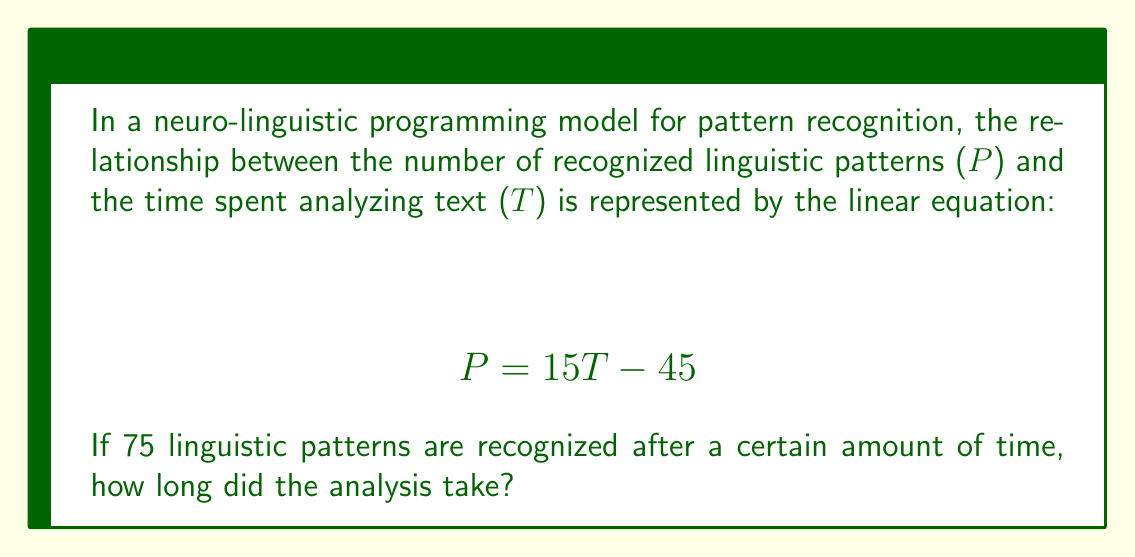What is the answer to this math problem? Let's solve this step-by-step:

1) We're given the linear equation: $P = 15T - 45$

2) We know that 75 patterns were recognized, so we can substitute P with 75:

   $75 = 15T - 45$

3) To solve for T, first add 45 to both sides:

   $75 + 45 = 15T - 45 + 45$
   $120 = 15T$

4) Now divide both sides by 15:

   $\frac{120}{15} = \frac{15T}{15}$
   $8 = T$

5) Therefore, the analysis took 8 time units.
Answer: $T = 8$ 